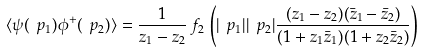Convert formula to latex. <formula><loc_0><loc_0><loc_500><loc_500>\langle \psi ( \ p _ { 1 } ) \phi ^ { + } ( \ p _ { 2 } ) \rangle = \frac { 1 } { z _ { 1 } - z _ { 2 } } \, f _ { 2 } \, \left ( | \ p _ { 1 } | | \ p _ { 2 } | \frac { ( z _ { 1 } - z _ { 2 } ) ( \bar { z } _ { 1 } - \bar { z } _ { 2 } ) } { ( 1 + z _ { 1 } \bar { z } _ { 1 } ) ( 1 + z _ { 2 } \bar { z } _ { 2 } ) } \right )</formula> 